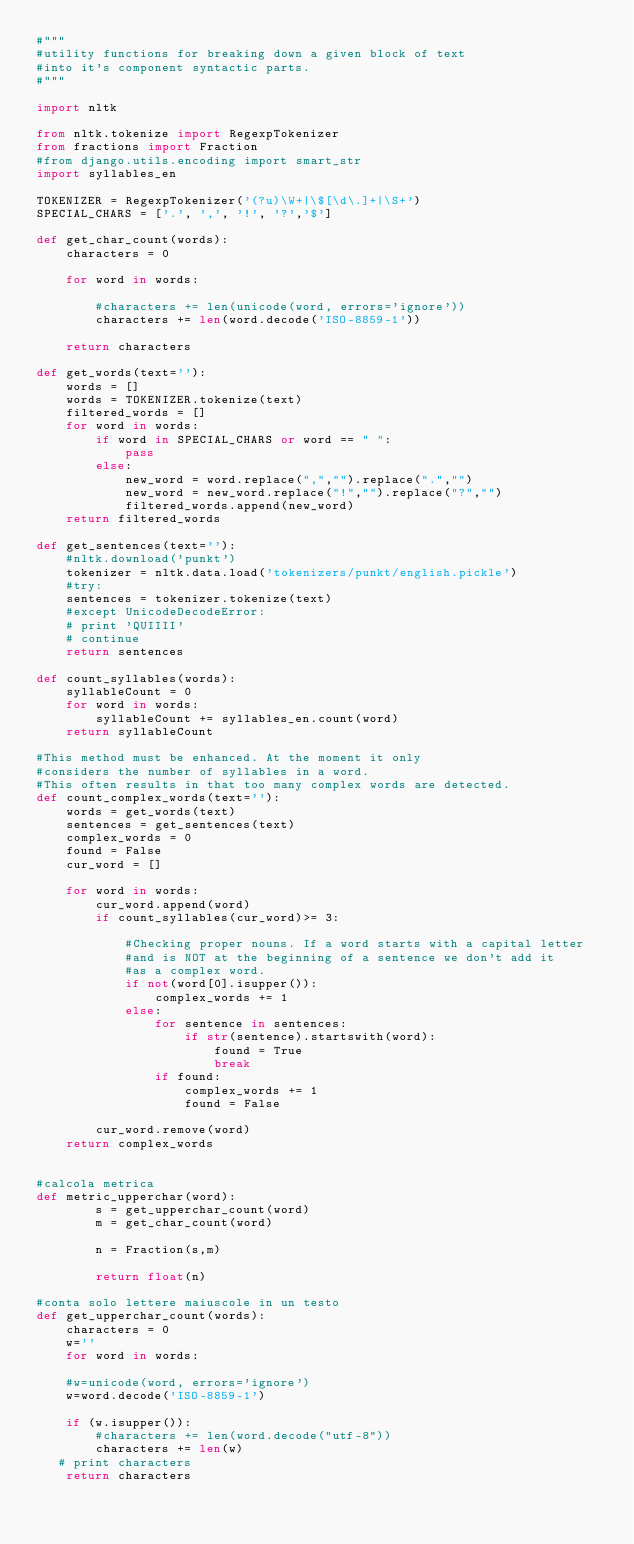Convert code to text. <code><loc_0><loc_0><loc_500><loc_500><_Python_>#"""
#utility functions for breaking down a given block of text
#into it's component syntactic parts.
#"""

import nltk

from nltk.tokenize import RegexpTokenizer
from fractions import Fraction
#from django.utils.encoding import smart_str
import syllables_en

TOKENIZER = RegexpTokenizer('(?u)\W+|\$[\d\.]+|\S+')
SPECIAL_CHARS = ['.', ',', '!', '?','$']

def get_char_count(words):
	characters = 0

	for word in words:
			
		#characters += len(unicode(word, errors='ignore'))
		characters += len(word.decode('ISO-8859-1'))
						
	return characters
    
def get_words(text=''):
    words = []
    words = TOKENIZER.tokenize(text)
    filtered_words = []
    for word in words:
        if word in SPECIAL_CHARS or word == " ":
            pass
        else:
            new_word = word.replace(",","").replace(".","")
            new_word = new_word.replace("!","").replace("?","")
            filtered_words.append(new_word)
    return filtered_words

def get_sentences(text=''):
    #nltk.download('punkt')
    tokenizer = nltk.data.load('tokenizers/punkt/english.pickle')
    #try:
    sentences = tokenizer.tokenize(text)
    #except UnicodeDecodeError:
	# print 'QUIIII'	 
	# continue
    return sentences

def count_syllables(words):
    syllableCount = 0
    for word in words:
        syllableCount += syllables_en.count(word)
    return syllableCount

#This method must be enhanced. At the moment it only
#considers the number of syllables in a word.
#This often results in that too many complex words are detected.
def count_complex_words(text=''):
    words = get_words(text)
    sentences = get_sentences(text)
    complex_words = 0
    found = False
    cur_word = []
    
    for word in words:          
        cur_word.append(word)
        if count_syllables(cur_word)>= 3:
            
            #Checking proper nouns. If a word starts with a capital letter
            #and is NOT at the beginning of a sentence we don't add it
            #as a complex word.
            if not(word[0].isupper()):
                complex_words += 1
            else:
                for sentence in sentences:
                    if str(sentence).startswith(word):
                        found = True
                        break
                if found: 
                    complex_words += 1
                    found = False
                
        cur_word.remove(word)
    return complex_words


#calcola metrica
def metric_upperchar(word):
        s = get_upperchar_count(word)
        m = get_char_count(word)

        n = Fraction(s,m)

        return float(n)

#conta solo lettere maiuscole in un testo
def get_upperchar_count(words):
    characters = 0
    w=''
    for word in words:
	
	#w=unicode(word, errors='ignore')
	w=word.decode('ISO-8859-1')
	
	if (w.isupper()):
		#characters += len(word.decode("utf-8"))
		characters += len(w)
   # print characters
    return characters

</code> 